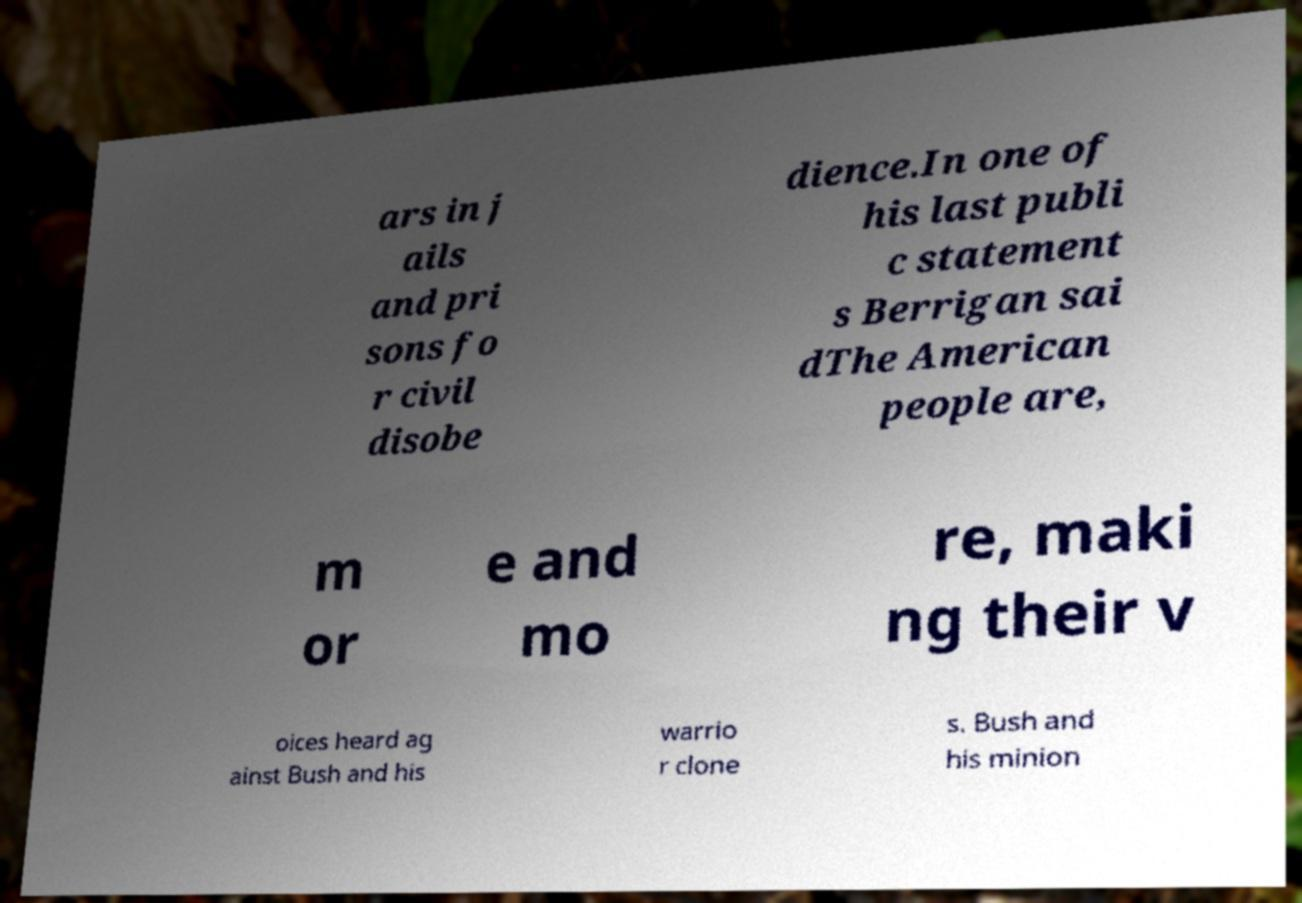Could you assist in decoding the text presented in this image and type it out clearly? ars in j ails and pri sons fo r civil disobe dience.In one of his last publi c statement s Berrigan sai dThe American people are, m or e and mo re, maki ng their v oices heard ag ainst Bush and his warrio r clone s. Bush and his minion 